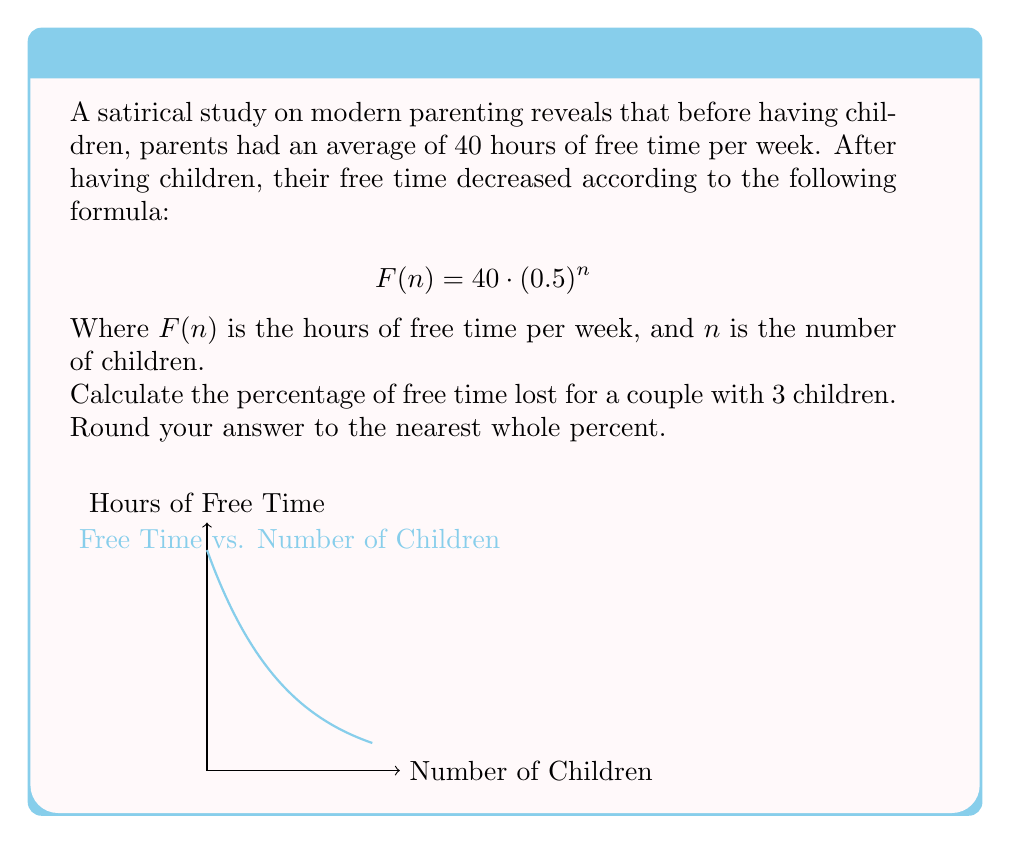Provide a solution to this math problem. Let's approach this step-by-step:

1) First, we need to calculate the free time with 3 children:
   $F(3) = 40 \cdot (0.5)^3 = 40 \cdot 0.125 = 5$ hours

2) Now, we can calculate the amount of free time lost:
   Original free time: 40 hours
   Free time with 3 children: 5 hours
   Time lost = $40 - 5 = 35$ hours

3) To calculate the percentage lost, we use the formula:
   $\text{Percentage lost} = \frac{\text{Amount lost}}{\text{Original amount}} \times 100\%$

4) Plugging in our values:
   $\text{Percentage lost} = \frac{35}{40} \times 100\% = 0.875 \times 100\% = 87.5\%$

5) Rounding to the nearest whole percent:
   $87.5\%$ rounds to $88\%$

Thus, the couple has lost 88% of their free time after having 3 children.
Answer: 88% 